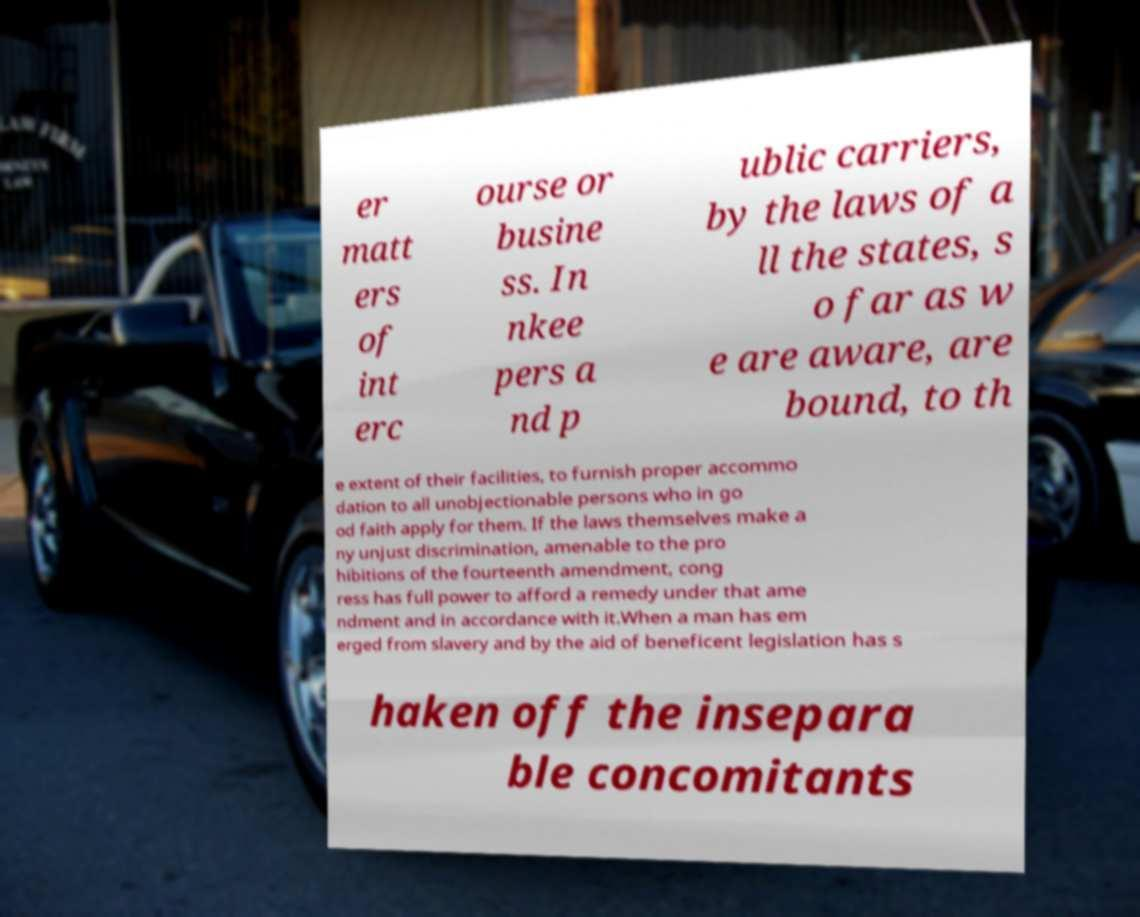Please identify and transcribe the text found in this image. er matt ers of int erc ourse or busine ss. In nkee pers a nd p ublic carriers, by the laws of a ll the states, s o far as w e are aware, are bound, to th e extent of their facilities, to furnish proper accommo dation to all unobjectionable persons who in go od faith apply for them. If the laws themselves make a ny unjust discrimination, amenable to the pro hibitions of the fourteenth amendment, cong ress has full power to afford a remedy under that ame ndment and in accordance with it.When a man has em erged from slavery and by the aid of beneficent legislation has s haken off the insepara ble concomitants 